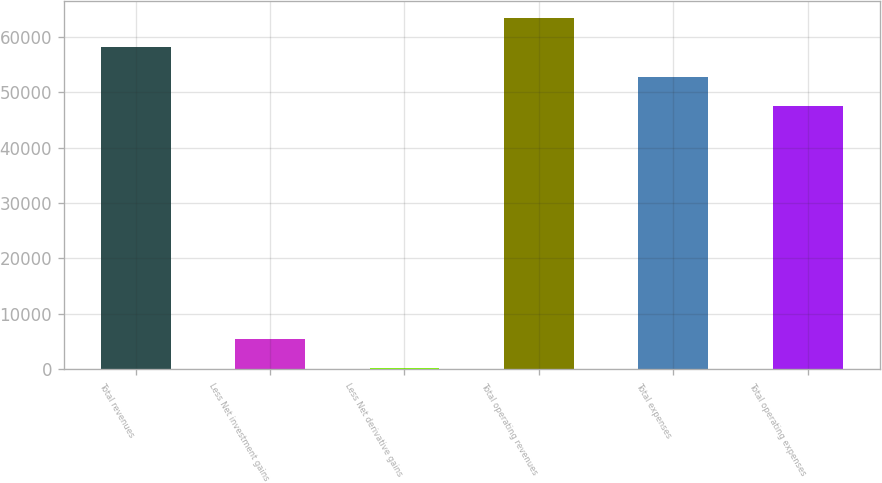<chart> <loc_0><loc_0><loc_500><loc_500><bar_chart><fcel>Total revenues<fcel>Less Net investment gains<fcel>Less Net derivative gains<fcel>Total operating revenues<fcel>Total expenses<fcel>Total operating expenses<nl><fcel>58045.8<fcel>5546.4<fcel>265<fcel>63327.2<fcel>52764.4<fcel>47483<nl></chart> 